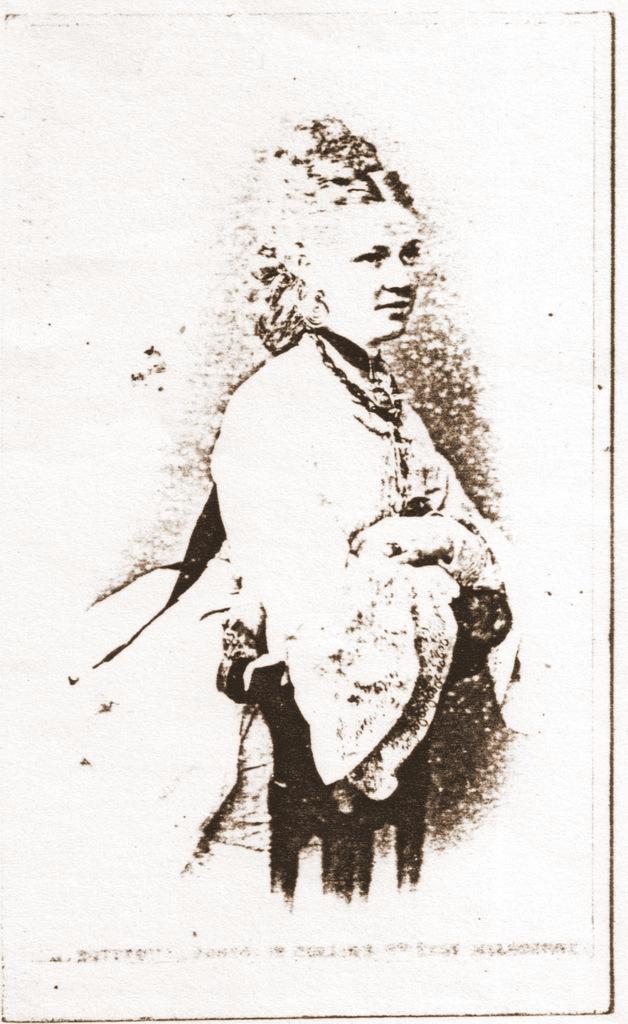Describe this image in one or two sentences. In the center of the image we can see a sketch of a person on the paper. 